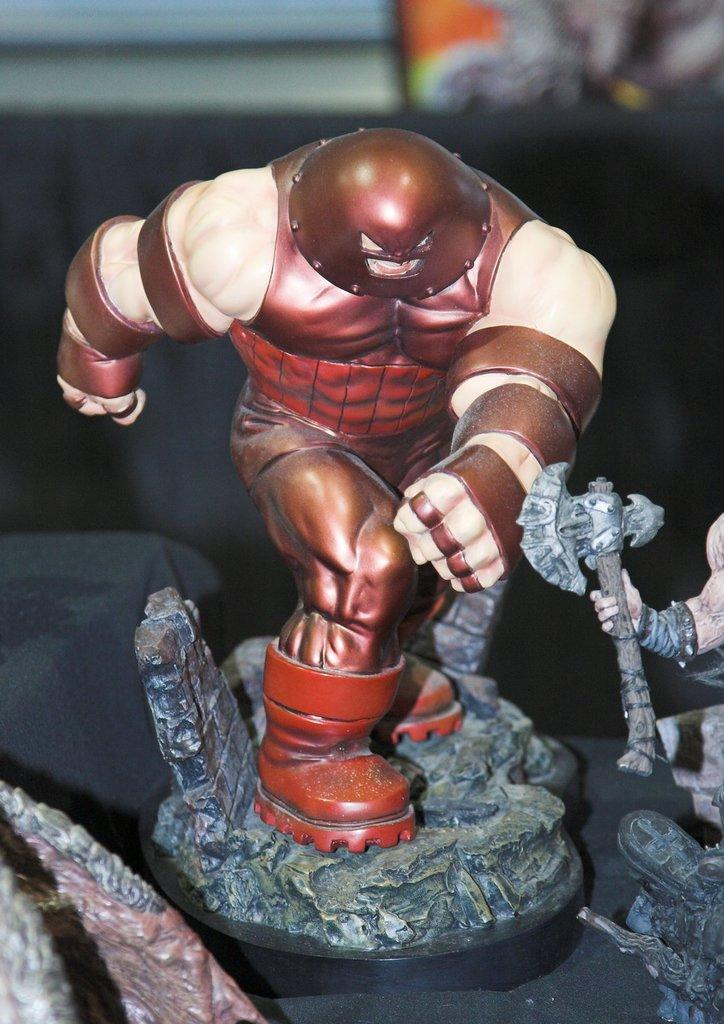What type of figurine is in the image? There is a figurine of a Marvel character in the image. What colors are used for the figurine? The figurine is in brown and cream color. Can you describe the background of the image? The background of the image is blurred. How many sisters are singing songs in the background of the image? There are no sisters or songs present in the image; it features a figurine of a Marvel character with a blurred background. 